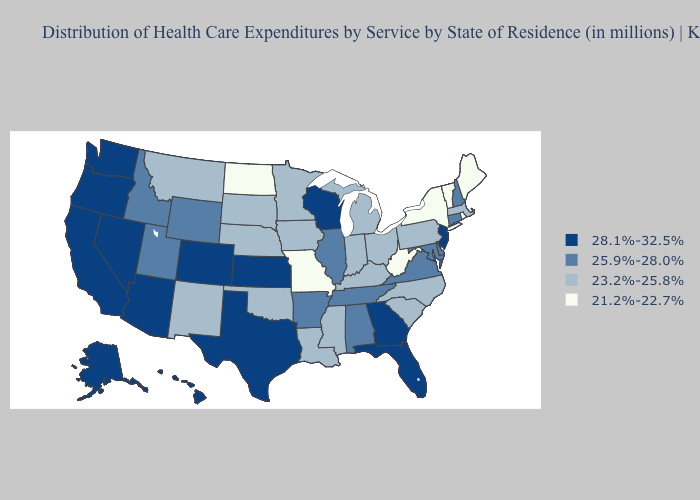Among the states that border Utah , does Idaho have the highest value?
Give a very brief answer. No. What is the lowest value in the USA?
Answer briefly. 21.2%-22.7%. Name the states that have a value in the range 28.1%-32.5%?
Answer briefly. Alaska, Arizona, California, Colorado, Florida, Georgia, Hawaii, Kansas, Nevada, New Jersey, Oregon, Texas, Washington, Wisconsin. Among the states that border Delaware , which have the lowest value?
Keep it brief. Pennsylvania. Among the states that border Wisconsin , which have the lowest value?
Concise answer only. Iowa, Michigan, Minnesota. Does Kentucky have a higher value than New Hampshire?
Be succinct. No. Among the states that border Arizona , which have the highest value?
Give a very brief answer. California, Colorado, Nevada. What is the lowest value in states that border Connecticut?
Write a very short answer. 21.2%-22.7%. Which states have the highest value in the USA?
Write a very short answer. Alaska, Arizona, California, Colorado, Florida, Georgia, Hawaii, Kansas, Nevada, New Jersey, Oregon, Texas, Washington, Wisconsin. What is the highest value in the USA?
Write a very short answer. 28.1%-32.5%. Name the states that have a value in the range 25.9%-28.0%?
Give a very brief answer. Alabama, Arkansas, Connecticut, Delaware, Idaho, Illinois, Maryland, New Hampshire, Tennessee, Utah, Virginia, Wyoming. Name the states that have a value in the range 21.2%-22.7%?
Keep it brief. Maine, Missouri, New York, North Dakota, Rhode Island, Vermont, West Virginia. Which states have the lowest value in the West?
Keep it brief. Montana, New Mexico. Does Alaska have the highest value in the USA?
Give a very brief answer. Yes. Name the states that have a value in the range 28.1%-32.5%?
Concise answer only. Alaska, Arizona, California, Colorado, Florida, Georgia, Hawaii, Kansas, Nevada, New Jersey, Oregon, Texas, Washington, Wisconsin. 